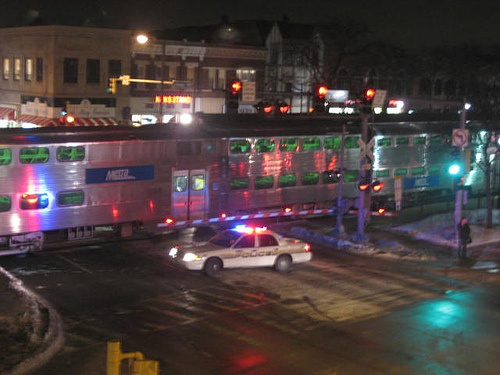Describe the objects in this image and their specific colors. I can see train in black, gray, purple, and maroon tones, car in black, gray, darkgray, and purple tones, traffic light in black, olive, and maroon tones, traffic light in black, maroon, and brown tones, and people in black and purple tones in this image. 